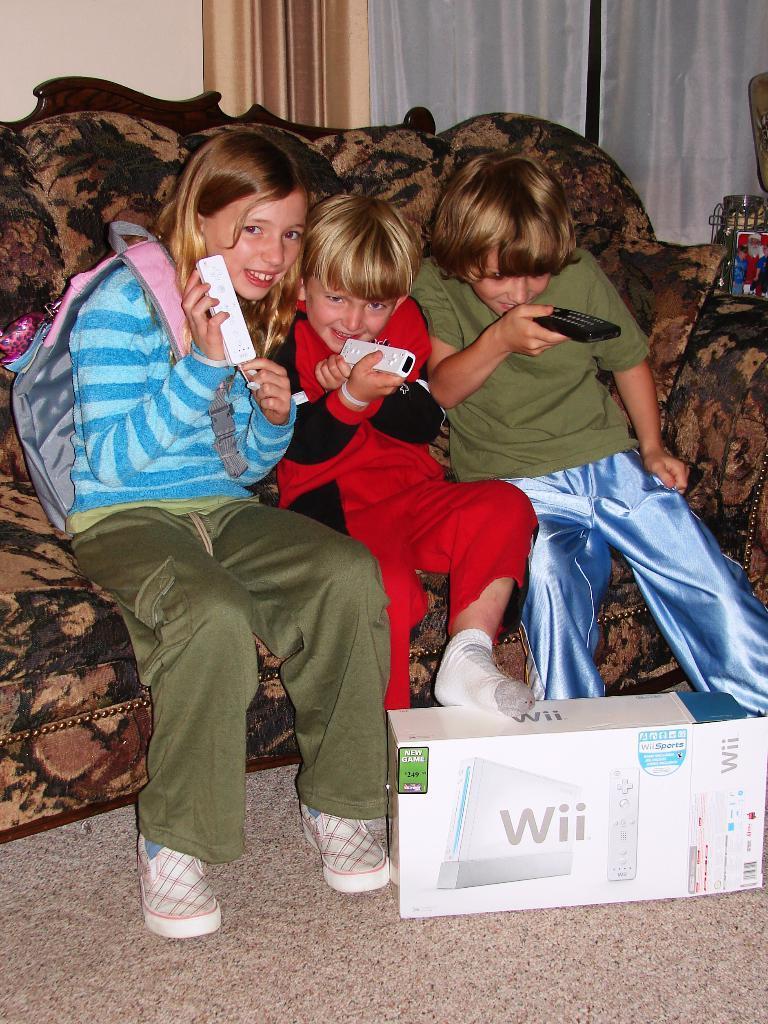Please provide a concise description of this image. In this picture we can see three kids sitting on the sofa and holding the remote in the hand, smiling and giving a pose to the camera. In the front there is a playstation box. In the background there is a white curtain. 